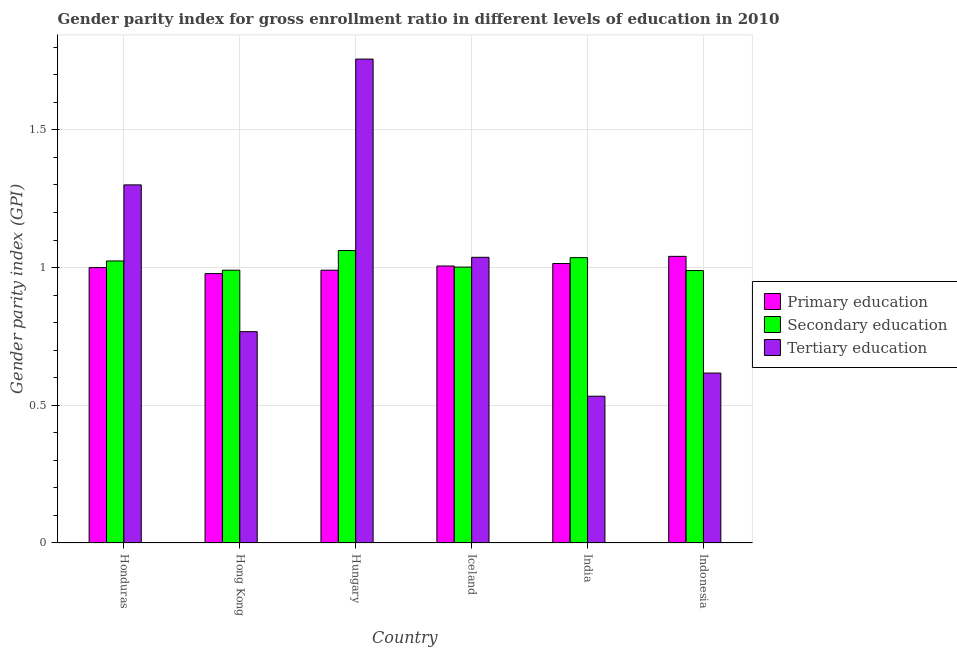Are the number of bars per tick equal to the number of legend labels?
Keep it short and to the point. Yes. How many bars are there on the 6th tick from the right?
Offer a terse response. 3. What is the label of the 6th group of bars from the left?
Your answer should be very brief. Indonesia. What is the gender parity index in primary education in Hong Kong?
Make the answer very short. 0.98. Across all countries, what is the maximum gender parity index in secondary education?
Give a very brief answer. 1.06. Across all countries, what is the minimum gender parity index in secondary education?
Your answer should be compact. 0.99. In which country was the gender parity index in primary education maximum?
Give a very brief answer. Indonesia. What is the total gender parity index in tertiary education in the graph?
Provide a short and direct response. 6.01. What is the difference between the gender parity index in primary education in Iceland and that in India?
Offer a very short reply. -0.01. What is the difference between the gender parity index in secondary education in Iceland and the gender parity index in tertiary education in India?
Offer a very short reply. 0.47. What is the average gender parity index in primary education per country?
Provide a short and direct response. 1. What is the difference between the gender parity index in tertiary education and gender parity index in secondary education in Hungary?
Keep it short and to the point. 0.7. What is the ratio of the gender parity index in tertiary education in Hungary to that in Indonesia?
Your answer should be very brief. 2.85. Is the gender parity index in primary education in Honduras less than that in Hong Kong?
Your answer should be compact. No. What is the difference between the highest and the second highest gender parity index in tertiary education?
Provide a succinct answer. 0.46. What is the difference between the highest and the lowest gender parity index in tertiary education?
Provide a short and direct response. 1.22. Is the sum of the gender parity index in primary education in Hong Kong and India greater than the maximum gender parity index in secondary education across all countries?
Offer a very short reply. Yes. What does the 3rd bar from the left in India represents?
Offer a very short reply. Tertiary education. What does the 2nd bar from the right in Iceland represents?
Your answer should be compact. Secondary education. Is it the case that in every country, the sum of the gender parity index in primary education and gender parity index in secondary education is greater than the gender parity index in tertiary education?
Make the answer very short. Yes. Are all the bars in the graph horizontal?
Provide a succinct answer. No. Are the values on the major ticks of Y-axis written in scientific E-notation?
Provide a succinct answer. No. Does the graph contain any zero values?
Make the answer very short. No. Does the graph contain grids?
Offer a very short reply. Yes. Where does the legend appear in the graph?
Provide a succinct answer. Center right. How many legend labels are there?
Your answer should be very brief. 3. How are the legend labels stacked?
Provide a short and direct response. Vertical. What is the title of the graph?
Give a very brief answer. Gender parity index for gross enrollment ratio in different levels of education in 2010. What is the label or title of the Y-axis?
Offer a very short reply. Gender parity index (GPI). What is the Gender parity index (GPI) in Primary education in Honduras?
Provide a succinct answer. 1. What is the Gender parity index (GPI) of Secondary education in Honduras?
Provide a short and direct response. 1.02. What is the Gender parity index (GPI) of Tertiary education in Honduras?
Offer a very short reply. 1.3. What is the Gender parity index (GPI) of Primary education in Hong Kong?
Make the answer very short. 0.98. What is the Gender parity index (GPI) of Secondary education in Hong Kong?
Offer a terse response. 0.99. What is the Gender parity index (GPI) of Tertiary education in Hong Kong?
Your answer should be very brief. 0.77. What is the Gender parity index (GPI) of Primary education in Hungary?
Keep it short and to the point. 0.99. What is the Gender parity index (GPI) of Secondary education in Hungary?
Ensure brevity in your answer.  1.06. What is the Gender parity index (GPI) in Tertiary education in Hungary?
Keep it short and to the point. 1.76. What is the Gender parity index (GPI) in Primary education in Iceland?
Provide a short and direct response. 1.01. What is the Gender parity index (GPI) of Secondary education in Iceland?
Make the answer very short. 1. What is the Gender parity index (GPI) of Tertiary education in Iceland?
Your answer should be compact. 1.04. What is the Gender parity index (GPI) of Primary education in India?
Keep it short and to the point. 1.01. What is the Gender parity index (GPI) of Secondary education in India?
Make the answer very short. 1.04. What is the Gender parity index (GPI) of Tertiary education in India?
Make the answer very short. 0.53. What is the Gender parity index (GPI) of Primary education in Indonesia?
Keep it short and to the point. 1.04. What is the Gender parity index (GPI) in Secondary education in Indonesia?
Offer a very short reply. 0.99. What is the Gender parity index (GPI) in Tertiary education in Indonesia?
Provide a short and direct response. 0.62. Across all countries, what is the maximum Gender parity index (GPI) in Primary education?
Make the answer very short. 1.04. Across all countries, what is the maximum Gender parity index (GPI) of Secondary education?
Your answer should be compact. 1.06. Across all countries, what is the maximum Gender parity index (GPI) in Tertiary education?
Your response must be concise. 1.76. Across all countries, what is the minimum Gender parity index (GPI) in Primary education?
Your answer should be compact. 0.98. Across all countries, what is the minimum Gender parity index (GPI) in Secondary education?
Give a very brief answer. 0.99. Across all countries, what is the minimum Gender parity index (GPI) in Tertiary education?
Keep it short and to the point. 0.53. What is the total Gender parity index (GPI) of Primary education in the graph?
Your answer should be very brief. 6.03. What is the total Gender parity index (GPI) in Secondary education in the graph?
Provide a short and direct response. 6.1. What is the total Gender parity index (GPI) in Tertiary education in the graph?
Your response must be concise. 6.01. What is the difference between the Gender parity index (GPI) in Primary education in Honduras and that in Hong Kong?
Keep it short and to the point. 0.02. What is the difference between the Gender parity index (GPI) in Secondary education in Honduras and that in Hong Kong?
Your response must be concise. 0.03. What is the difference between the Gender parity index (GPI) of Tertiary education in Honduras and that in Hong Kong?
Provide a short and direct response. 0.53. What is the difference between the Gender parity index (GPI) in Primary education in Honduras and that in Hungary?
Your response must be concise. 0.01. What is the difference between the Gender parity index (GPI) in Secondary education in Honduras and that in Hungary?
Provide a succinct answer. -0.04. What is the difference between the Gender parity index (GPI) of Tertiary education in Honduras and that in Hungary?
Offer a very short reply. -0.46. What is the difference between the Gender parity index (GPI) of Primary education in Honduras and that in Iceland?
Provide a succinct answer. -0.01. What is the difference between the Gender parity index (GPI) in Secondary education in Honduras and that in Iceland?
Your answer should be compact. 0.02. What is the difference between the Gender parity index (GPI) of Tertiary education in Honduras and that in Iceland?
Make the answer very short. 0.26. What is the difference between the Gender parity index (GPI) of Primary education in Honduras and that in India?
Your answer should be compact. -0.01. What is the difference between the Gender parity index (GPI) in Secondary education in Honduras and that in India?
Provide a short and direct response. -0.01. What is the difference between the Gender parity index (GPI) in Tertiary education in Honduras and that in India?
Your answer should be very brief. 0.77. What is the difference between the Gender parity index (GPI) in Primary education in Honduras and that in Indonesia?
Provide a succinct answer. -0.04. What is the difference between the Gender parity index (GPI) of Secondary education in Honduras and that in Indonesia?
Provide a short and direct response. 0.03. What is the difference between the Gender parity index (GPI) in Tertiary education in Honduras and that in Indonesia?
Your response must be concise. 0.68. What is the difference between the Gender parity index (GPI) of Primary education in Hong Kong and that in Hungary?
Offer a terse response. -0.01. What is the difference between the Gender parity index (GPI) of Secondary education in Hong Kong and that in Hungary?
Offer a very short reply. -0.07. What is the difference between the Gender parity index (GPI) of Tertiary education in Hong Kong and that in Hungary?
Provide a short and direct response. -0.99. What is the difference between the Gender parity index (GPI) of Primary education in Hong Kong and that in Iceland?
Give a very brief answer. -0.03. What is the difference between the Gender parity index (GPI) in Secondary education in Hong Kong and that in Iceland?
Give a very brief answer. -0.01. What is the difference between the Gender parity index (GPI) of Tertiary education in Hong Kong and that in Iceland?
Give a very brief answer. -0.27. What is the difference between the Gender parity index (GPI) in Primary education in Hong Kong and that in India?
Your answer should be very brief. -0.04. What is the difference between the Gender parity index (GPI) of Secondary education in Hong Kong and that in India?
Your response must be concise. -0.05. What is the difference between the Gender parity index (GPI) in Tertiary education in Hong Kong and that in India?
Ensure brevity in your answer.  0.23. What is the difference between the Gender parity index (GPI) of Primary education in Hong Kong and that in Indonesia?
Provide a short and direct response. -0.06. What is the difference between the Gender parity index (GPI) in Secondary education in Hong Kong and that in Indonesia?
Your response must be concise. 0. What is the difference between the Gender parity index (GPI) in Tertiary education in Hong Kong and that in Indonesia?
Make the answer very short. 0.15. What is the difference between the Gender parity index (GPI) of Primary education in Hungary and that in Iceland?
Give a very brief answer. -0.02. What is the difference between the Gender parity index (GPI) of Secondary education in Hungary and that in Iceland?
Provide a short and direct response. 0.06. What is the difference between the Gender parity index (GPI) of Tertiary education in Hungary and that in Iceland?
Offer a very short reply. 0.72. What is the difference between the Gender parity index (GPI) in Primary education in Hungary and that in India?
Keep it short and to the point. -0.02. What is the difference between the Gender parity index (GPI) in Secondary education in Hungary and that in India?
Provide a succinct answer. 0.03. What is the difference between the Gender parity index (GPI) of Tertiary education in Hungary and that in India?
Your answer should be very brief. 1.22. What is the difference between the Gender parity index (GPI) of Primary education in Hungary and that in Indonesia?
Ensure brevity in your answer.  -0.05. What is the difference between the Gender parity index (GPI) in Secondary education in Hungary and that in Indonesia?
Offer a very short reply. 0.07. What is the difference between the Gender parity index (GPI) in Tertiary education in Hungary and that in Indonesia?
Your response must be concise. 1.14. What is the difference between the Gender parity index (GPI) of Primary education in Iceland and that in India?
Your response must be concise. -0.01. What is the difference between the Gender parity index (GPI) of Secondary education in Iceland and that in India?
Your answer should be very brief. -0.03. What is the difference between the Gender parity index (GPI) in Tertiary education in Iceland and that in India?
Your answer should be very brief. 0.5. What is the difference between the Gender parity index (GPI) of Primary education in Iceland and that in Indonesia?
Your response must be concise. -0.04. What is the difference between the Gender parity index (GPI) of Secondary education in Iceland and that in Indonesia?
Your answer should be compact. 0.01. What is the difference between the Gender parity index (GPI) in Tertiary education in Iceland and that in Indonesia?
Offer a very short reply. 0.42. What is the difference between the Gender parity index (GPI) of Primary education in India and that in Indonesia?
Provide a succinct answer. -0.03. What is the difference between the Gender parity index (GPI) of Secondary education in India and that in Indonesia?
Give a very brief answer. 0.05. What is the difference between the Gender parity index (GPI) of Tertiary education in India and that in Indonesia?
Keep it short and to the point. -0.08. What is the difference between the Gender parity index (GPI) of Primary education in Honduras and the Gender parity index (GPI) of Secondary education in Hong Kong?
Your response must be concise. 0.01. What is the difference between the Gender parity index (GPI) in Primary education in Honduras and the Gender parity index (GPI) in Tertiary education in Hong Kong?
Provide a short and direct response. 0.23. What is the difference between the Gender parity index (GPI) of Secondary education in Honduras and the Gender parity index (GPI) of Tertiary education in Hong Kong?
Give a very brief answer. 0.26. What is the difference between the Gender parity index (GPI) of Primary education in Honduras and the Gender parity index (GPI) of Secondary education in Hungary?
Make the answer very short. -0.06. What is the difference between the Gender parity index (GPI) of Primary education in Honduras and the Gender parity index (GPI) of Tertiary education in Hungary?
Make the answer very short. -0.76. What is the difference between the Gender parity index (GPI) in Secondary education in Honduras and the Gender parity index (GPI) in Tertiary education in Hungary?
Keep it short and to the point. -0.73. What is the difference between the Gender parity index (GPI) of Primary education in Honduras and the Gender parity index (GPI) of Secondary education in Iceland?
Ensure brevity in your answer.  -0. What is the difference between the Gender parity index (GPI) in Primary education in Honduras and the Gender parity index (GPI) in Tertiary education in Iceland?
Provide a short and direct response. -0.04. What is the difference between the Gender parity index (GPI) in Secondary education in Honduras and the Gender parity index (GPI) in Tertiary education in Iceland?
Your answer should be compact. -0.01. What is the difference between the Gender parity index (GPI) in Primary education in Honduras and the Gender parity index (GPI) in Secondary education in India?
Ensure brevity in your answer.  -0.04. What is the difference between the Gender parity index (GPI) in Primary education in Honduras and the Gender parity index (GPI) in Tertiary education in India?
Ensure brevity in your answer.  0.47. What is the difference between the Gender parity index (GPI) of Secondary education in Honduras and the Gender parity index (GPI) of Tertiary education in India?
Give a very brief answer. 0.49. What is the difference between the Gender parity index (GPI) in Primary education in Honduras and the Gender parity index (GPI) in Secondary education in Indonesia?
Offer a terse response. 0.01. What is the difference between the Gender parity index (GPI) in Primary education in Honduras and the Gender parity index (GPI) in Tertiary education in Indonesia?
Ensure brevity in your answer.  0.38. What is the difference between the Gender parity index (GPI) of Secondary education in Honduras and the Gender parity index (GPI) of Tertiary education in Indonesia?
Your answer should be compact. 0.41. What is the difference between the Gender parity index (GPI) in Primary education in Hong Kong and the Gender parity index (GPI) in Secondary education in Hungary?
Make the answer very short. -0.08. What is the difference between the Gender parity index (GPI) of Primary education in Hong Kong and the Gender parity index (GPI) of Tertiary education in Hungary?
Your response must be concise. -0.78. What is the difference between the Gender parity index (GPI) in Secondary education in Hong Kong and the Gender parity index (GPI) in Tertiary education in Hungary?
Provide a succinct answer. -0.77. What is the difference between the Gender parity index (GPI) of Primary education in Hong Kong and the Gender parity index (GPI) of Secondary education in Iceland?
Provide a short and direct response. -0.02. What is the difference between the Gender parity index (GPI) in Primary education in Hong Kong and the Gender parity index (GPI) in Tertiary education in Iceland?
Offer a very short reply. -0.06. What is the difference between the Gender parity index (GPI) in Secondary education in Hong Kong and the Gender parity index (GPI) in Tertiary education in Iceland?
Offer a terse response. -0.05. What is the difference between the Gender parity index (GPI) in Primary education in Hong Kong and the Gender parity index (GPI) in Secondary education in India?
Your answer should be very brief. -0.06. What is the difference between the Gender parity index (GPI) in Primary education in Hong Kong and the Gender parity index (GPI) in Tertiary education in India?
Make the answer very short. 0.45. What is the difference between the Gender parity index (GPI) of Secondary education in Hong Kong and the Gender parity index (GPI) of Tertiary education in India?
Provide a succinct answer. 0.46. What is the difference between the Gender parity index (GPI) of Primary education in Hong Kong and the Gender parity index (GPI) of Secondary education in Indonesia?
Ensure brevity in your answer.  -0.01. What is the difference between the Gender parity index (GPI) in Primary education in Hong Kong and the Gender parity index (GPI) in Tertiary education in Indonesia?
Give a very brief answer. 0.36. What is the difference between the Gender parity index (GPI) of Secondary education in Hong Kong and the Gender parity index (GPI) of Tertiary education in Indonesia?
Your response must be concise. 0.37. What is the difference between the Gender parity index (GPI) in Primary education in Hungary and the Gender parity index (GPI) in Secondary education in Iceland?
Give a very brief answer. -0.01. What is the difference between the Gender parity index (GPI) in Primary education in Hungary and the Gender parity index (GPI) in Tertiary education in Iceland?
Provide a short and direct response. -0.05. What is the difference between the Gender parity index (GPI) in Secondary education in Hungary and the Gender parity index (GPI) in Tertiary education in Iceland?
Offer a very short reply. 0.02. What is the difference between the Gender parity index (GPI) of Primary education in Hungary and the Gender parity index (GPI) of Secondary education in India?
Keep it short and to the point. -0.05. What is the difference between the Gender parity index (GPI) in Primary education in Hungary and the Gender parity index (GPI) in Tertiary education in India?
Your answer should be very brief. 0.46. What is the difference between the Gender parity index (GPI) in Secondary education in Hungary and the Gender parity index (GPI) in Tertiary education in India?
Give a very brief answer. 0.53. What is the difference between the Gender parity index (GPI) in Primary education in Hungary and the Gender parity index (GPI) in Secondary education in Indonesia?
Provide a succinct answer. 0. What is the difference between the Gender parity index (GPI) of Primary education in Hungary and the Gender parity index (GPI) of Tertiary education in Indonesia?
Your answer should be very brief. 0.37. What is the difference between the Gender parity index (GPI) of Secondary education in Hungary and the Gender parity index (GPI) of Tertiary education in Indonesia?
Offer a very short reply. 0.44. What is the difference between the Gender parity index (GPI) in Primary education in Iceland and the Gender parity index (GPI) in Secondary education in India?
Provide a succinct answer. -0.03. What is the difference between the Gender parity index (GPI) of Primary education in Iceland and the Gender parity index (GPI) of Tertiary education in India?
Offer a terse response. 0.47. What is the difference between the Gender parity index (GPI) of Secondary education in Iceland and the Gender parity index (GPI) of Tertiary education in India?
Keep it short and to the point. 0.47. What is the difference between the Gender parity index (GPI) in Primary education in Iceland and the Gender parity index (GPI) in Secondary education in Indonesia?
Keep it short and to the point. 0.02. What is the difference between the Gender parity index (GPI) of Primary education in Iceland and the Gender parity index (GPI) of Tertiary education in Indonesia?
Offer a very short reply. 0.39. What is the difference between the Gender parity index (GPI) in Secondary education in Iceland and the Gender parity index (GPI) in Tertiary education in Indonesia?
Provide a succinct answer. 0.38. What is the difference between the Gender parity index (GPI) of Primary education in India and the Gender parity index (GPI) of Secondary education in Indonesia?
Offer a terse response. 0.03. What is the difference between the Gender parity index (GPI) of Primary education in India and the Gender parity index (GPI) of Tertiary education in Indonesia?
Make the answer very short. 0.4. What is the difference between the Gender parity index (GPI) in Secondary education in India and the Gender parity index (GPI) in Tertiary education in Indonesia?
Your response must be concise. 0.42. What is the average Gender parity index (GPI) of Primary education per country?
Keep it short and to the point. 1. What is the average Gender parity index (GPI) of Secondary education per country?
Offer a terse response. 1.02. What is the difference between the Gender parity index (GPI) in Primary education and Gender parity index (GPI) in Secondary education in Honduras?
Provide a short and direct response. -0.02. What is the difference between the Gender parity index (GPI) of Primary education and Gender parity index (GPI) of Tertiary education in Honduras?
Ensure brevity in your answer.  -0.3. What is the difference between the Gender parity index (GPI) in Secondary education and Gender parity index (GPI) in Tertiary education in Honduras?
Your answer should be compact. -0.28. What is the difference between the Gender parity index (GPI) of Primary education and Gender parity index (GPI) of Secondary education in Hong Kong?
Provide a short and direct response. -0.01. What is the difference between the Gender parity index (GPI) of Primary education and Gender parity index (GPI) of Tertiary education in Hong Kong?
Your answer should be very brief. 0.21. What is the difference between the Gender parity index (GPI) in Secondary education and Gender parity index (GPI) in Tertiary education in Hong Kong?
Offer a terse response. 0.22. What is the difference between the Gender parity index (GPI) in Primary education and Gender parity index (GPI) in Secondary education in Hungary?
Offer a terse response. -0.07. What is the difference between the Gender parity index (GPI) of Primary education and Gender parity index (GPI) of Tertiary education in Hungary?
Ensure brevity in your answer.  -0.77. What is the difference between the Gender parity index (GPI) of Secondary education and Gender parity index (GPI) of Tertiary education in Hungary?
Provide a short and direct response. -0.7. What is the difference between the Gender parity index (GPI) of Primary education and Gender parity index (GPI) of Secondary education in Iceland?
Your response must be concise. 0. What is the difference between the Gender parity index (GPI) of Primary education and Gender parity index (GPI) of Tertiary education in Iceland?
Ensure brevity in your answer.  -0.03. What is the difference between the Gender parity index (GPI) of Secondary education and Gender parity index (GPI) of Tertiary education in Iceland?
Provide a succinct answer. -0.04. What is the difference between the Gender parity index (GPI) in Primary education and Gender parity index (GPI) in Secondary education in India?
Your response must be concise. -0.02. What is the difference between the Gender parity index (GPI) in Primary education and Gender parity index (GPI) in Tertiary education in India?
Your response must be concise. 0.48. What is the difference between the Gender parity index (GPI) in Secondary education and Gender parity index (GPI) in Tertiary education in India?
Your answer should be compact. 0.5. What is the difference between the Gender parity index (GPI) of Primary education and Gender parity index (GPI) of Secondary education in Indonesia?
Offer a very short reply. 0.05. What is the difference between the Gender parity index (GPI) of Primary education and Gender parity index (GPI) of Tertiary education in Indonesia?
Your response must be concise. 0.42. What is the difference between the Gender parity index (GPI) in Secondary education and Gender parity index (GPI) in Tertiary education in Indonesia?
Your answer should be very brief. 0.37. What is the ratio of the Gender parity index (GPI) of Primary education in Honduras to that in Hong Kong?
Ensure brevity in your answer.  1.02. What is the ratio of the Gender parity index (GPI) in Secondary education in Honduras to that in Hong Kong?
Your answer should be compact. 1.03. What is the ratio of the Gender parity index (GPI) in Tertiary education in Honduras to that in Hong Kong?
Your answer should be compact. 1.69. What is the ratio of the Gender parity index (GPI) in Primary education in Honduras to that in Hungary?
Ensure brevity in your answer.  1.01. What is the ratio of the Gender parity index (GPI) of Secondary education in Honduras to that in Hungary?
Your response must be concise. 0.96. What is the ratio of the Gender parity index (GPI) of Tertiary education in Honduras to that in Hungary?
Offer a very short reply. 0.74. What is the ratio of the Gender parity index (GPI) in Secondary education in Honduras to that in Iceland?
Provide a succinct answer. 1.02. What is the ratio of the Gender parity index (GPI) of Tertiary education in Honduras to that in Iceland?
Your answer should be compact. 1.25. What is the ratio of the Gender parity index (GPI) of Primary education in Honduras to that in India?
Keep it short and to the point. 0.99. What is the ratio of the Gender parity index (GPI) in Secondary education in Honduras to that in India?
Make the answer very short. 0.99. What is the ratio of the Gender parity index (GPI) of Tertiary education in Honduras to that in India?
Offer a very short reply. 2.44. What is the ratio of the Gender parity index (GPI) in Primary education in Honduras to that in Indonesia?
Offer a terse response. 0.96. What is the ratio of the Gender parity index (GPI) of Secondary education in Honduras to that in Indonesia?
Offer a terse response. 1.04. What is the ratio of the Gender parity index (GPI) in Tertiary education in Honduras to that in Indonesia?
Make the answer very short. 2.11. What is the ratio of the Gender parity index (GPI) in Primary education in Hong Kong to that in Hungary?
Make the answer very short. 0.99. What is the ratio of the Gender parity index (GPI) of Secondary education in Hong Kong to that in Hungary?
Make the answer very short. 0.93. What is the ratio of the Gender parity index (GPI) of Tertiary education in Hong Kong to that in Hungary?
Give a very brief answer. 0.44. What is the ratio of the Gender parity index (GPI) of Primary education in Hong Kong to that in Iceland?
Provide a short and direct response. 0.97. What is the ratio of the Gender parity index (GPI) in Secondary education in Hong Kong to that in Iceland?
Provide a succinct answer. 0.99. What is the ratio of the Gender parity index (GPI) of Tertiary education in Hong Kong to that in Iceland?
Your response must be concise. 0.74. What is the ratio of the Gender parity index (GPI) in Primary education in Hong Kong to that in India?
Ensure brevity in your answer.  0.96. What is the ratio of the Gender parity index (GPI) of Secondary education in Hong Kong to that in India?
Provide a succinct answer. 0.96. What is the ratio of the Gender parity index (GPI) in Tertiary education in Hong Kong to that in India?
Keep it short and to the point. 1.44. What is the ratio of the Gender parity index (GPI) in Primary education in Hong Kong to that in Indonesia?
Offer a very short reply. 0.94. What is the ratio of the Gender parity index (GPI) of Tertiary education in Hong Kong to that in Indonesia?
Offer a terse response. 1.24. What is the ratio of the Gender parity index (GPI) in Primary education in Hungary to that in Iceland?
Make the answer very short. 0.98. What is the ratio of the Gender parity index (GPI) of Secondary education in Hungary to that in Iceland?
Offer a terse response. 1.06. What is the ratio of the Gender parity index (GPI) in Tertiary education in Hungary to that in Iceland?
Offer a very short reply. 1.69. What is the ratio of the Gender parity index (GPI) in Primary education in Hungary to that in India?
Keep it short and to the point. 0.98. What is the ratio of the Gender parity index (GPI) of Secondary education in Hungary to that in India?
Your answer should be compact. 1.02. What is the ratio of the Gender parity index (GPI) in Tertiary education in Hungary to that in India?
Give a very brief answer. 3.3. What is the ratio of the Gender parity index (GPI) of Primary education in Hungary to that in Indonesia?
Ensure brevity in your answer.  0.95. What is the ratio of the Gender parity index (GPI) in Secondary education in Hungary to that in Indonesia?
Offer a very short reply. 1.07. What is the ratio of the Gender parity index (GPI) in Tertiary education in Hungary to that in Indonesia?
Provide a succinct answer. 2.85. What is the ratio of the Gender parity index (GPI) in Secondary education in Iceland to that in India?
Ensure brevity in your answer.  0.97. What is the ratio of the Gender parity index (GPI) in Tertiary education in Iceland to that in India?
Your response must be concise. 1.95. What is the ratio of the Gender parity index (GPI) of Primary education in Iceland to that in Indonesia?
Your answer should be very brief. 0.97. What is the ratio of the Gender parity index (GPI) in Secondary education in Iceland to that in Indonesia?
Your response must be concise. 1.01. What is the ratio of the Gender parity index (GPI) of Tertiary education in Iceland to that in Indonesia?
Provide a succinct answer. 1.68. What is the ratio of the Gender parity index (GPI) of Primary education in India to that in Indonesia?
Provide a succinct answer. 0.97. What is the ratio of the Gender parity index (GPI) in Secondary education in India to that in Indonesia?
Provide a short and direct response. 1.05. What is the ratio of the Gender parity index (GPI) in Tertiary education in India to that in Indonesia?
Provide a succinct answer. 0.86. What is the difference between the highest and the second highest Gender parity index (GPI) of Primary education?
Your answer should be compact. 0.03. What is the difference between the highest and the second highest Gender parity index (GPI) of Secondary education?
Your answer should be very brief. 0.03. What is the difference between the highest and the second highest Gender parity index (GPI) of Tertiary education?
Give a very brief answer. 0.46. What is the difference between the highest and the lowest Gender parity index (GPI) of Primary education?
Your response must be concise. 0.06. What is the difference between the highest and the lowest Gender parity index (GPI) in Secondary education?
Your answer should be compact. 0.07. What is the difference between the highest and the lowest Gender parity index (GPI) in Tertiary education?
Provide a succinct answer. 1.22. 